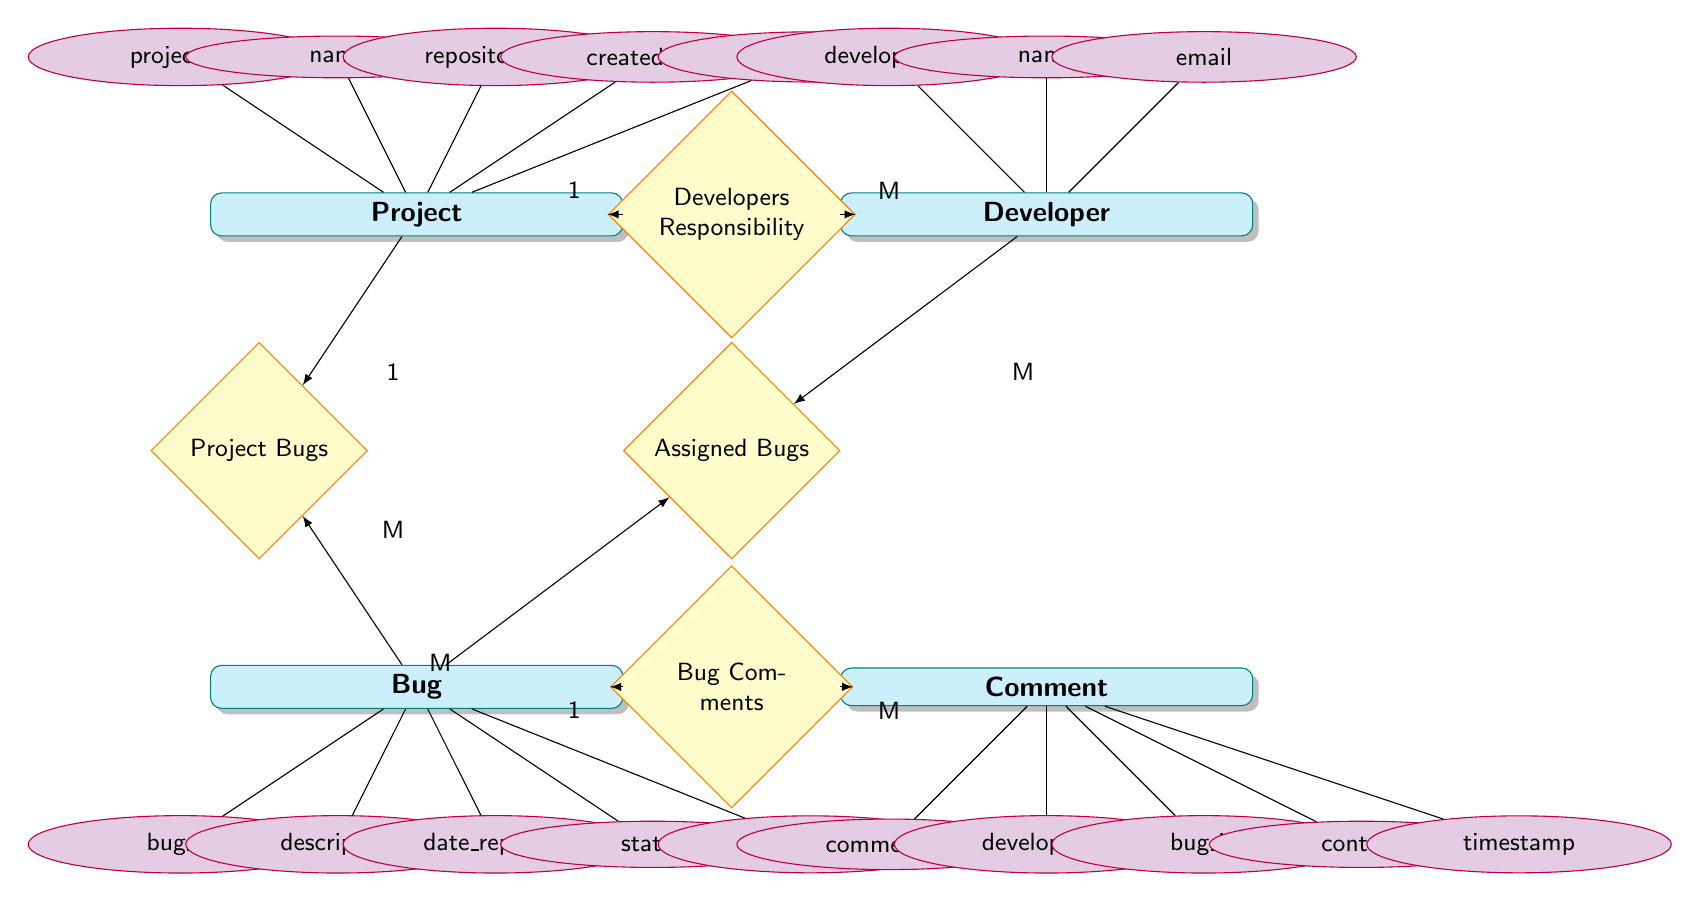What is the primary key for the Project entity? The primary key is indicated by the attribute that uniquely identifies each record in the Project entity. In this case, the attribute is project_id, which is listed under the Project entity.
Answer: project_id How many attributes does the Bug entity have? The Bug entity has a total of five attributes listed below it: bug_id, description, date_reported, status, and severity. Counting these, we find there are five attributes.
Answer: 5 What type of relationship exists between Project and Bug? The diagram shows a "1-to-Many" relationship from Project to Bug, which means one project can have multiple bugs associated with it. This is clearly labeled in the relationship connecting these two entities.
Answer: 1-to-Many What is the maximum number of comments that can be linked to a single Bug? Each Bug can have multiple comments associated with it as indicated by the relationship type "1-to-Many" between Bug and Comment. Therefore, there is no defined maximum; it can be as many as needed.
Answer: Many Which entity does the attribute "developer_id" belong to? The attribute "developer_id" is listed directly under the Developer entity in the diagram, which shows that it is an attribute of that entity.
Answer: Developer What is the relationship label between Developer and Bug? The relationship label shown between Developer and Bug is "Assigned Bugs". This indicates that bugs can be assigned to developers, establishing a connection between these two entities.
Answer: Assigned Bugs How many relationships are there in total connecting the Bug entity? The Bug entity has three relationships connecting it to other entities: "Project Origin" to Project, "Assigned Developers" to Developer, and "Bug Comments" to Comment. Counting these gives a total of three relationships.
Answer: 3 What is the severity level attribute used for? The severity attribute in the Bug entity is meant to indicate the severity level of the bug being reported. It helps categorize the bug's impact on the project.
Answer: Severity level What does the relationship "Developers Responsibility" indicate? The "Developers Responsibility" relationship indicates that multiple developers are responsible for the project, and each project has this relationship established to signify its developers.
Answer: Multiple developers What type of relationship is displayed between Developer and Bug? The relationship displayed between Developer and Bug is a "Many-to-Many" relationship, showing that a developer can be assigned multiple bugs, and a bug can be assigned to multiple developers.
Answer: Many-to-Many 